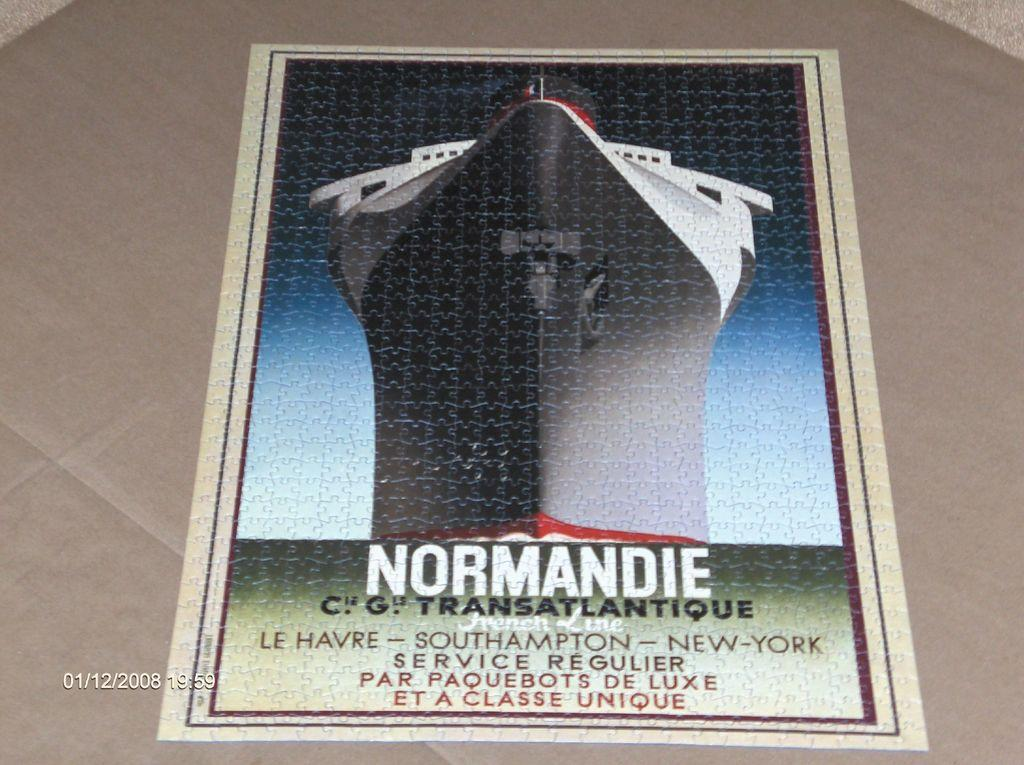<image>
Relay a brief, clear account of the picture shown. A puzzle that is put together and reads Normandie in large white letters. 